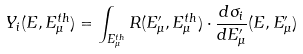Convert formula to latex. <formula><loc_0><loc_0><loc_500><loc_500>Y _ { i } ( E , E _ { \mu } ^ { t h } ) = \int _ { E _ { \mu } ^ { t h } } R ( E _ { \mu } ^ { \prime } , E _ { \mu } ^ { t h } ) \cdot \frac { d \sigma _ { i } } { d E _ { \mu } ^ { \prime } } ( E , E _ { \mu } ^ { \prime } )</formula> 